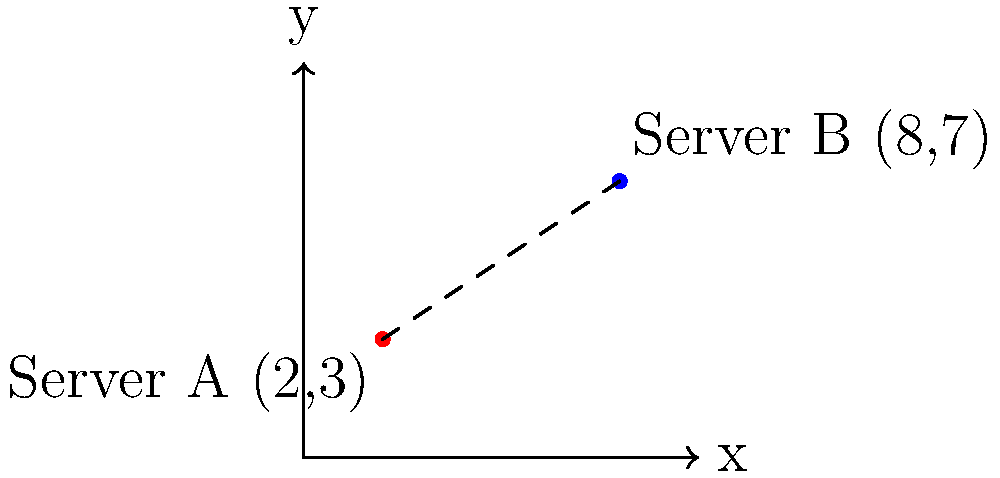Two servers are located on a coordinate plane representing their geographic positions. Server A is at (2,3) and Server B is at (8,7). If each unit on the coordinate plane represents 100 km, what is the latency between these two servers, given that the signal travels at 200,000 km/s? Round your answer to the nearest millisecond. To solve this problem, we need to follow these steps:

1. Calculate the distance between the two points using the distance formula:
   $$d = \sqrt{(x_2-x_1)^2 + (y_2-y_1)^2}$$

2. Substitute the coordinates:
   $$d = \sqrt{(8-2)^2 + (7-3)^2}$$

3. Simplify:
   $$d = \sqrt{6^2 + 4^2} = \sqrt{36 + 16} = \sqrt{52}$$

4. Calculate the actual distance:
   Each unit represents 100 km, so the actual distance is:
   $$\text{Actual distance} = \sqrt{52} \times 100 \text{ km}$$

5. Calculate the time taken for the signal to travel this distance:
   $$\text{Time} = \frac{\text{Distance}}{\text{Speed}}$$
   $$\text{Time} = \frac{\sqrt{52} \times 100 \text{ km}}{200,000 \text{ km/s}}$$

6. Simplify and convert to milliseconds:
   $$\text{Time} = \frac{\sqrt{52}}{2000} \text{ s} \times 1000 \text{ ms/s}$$

7. Calculate and round to the nearest millisecond:
   $$\text{Time} \approx 3.61 \text{ ms}$$

Therefore, the latency between the two servers is approximately 4 ms.
Answer: 4 ms 